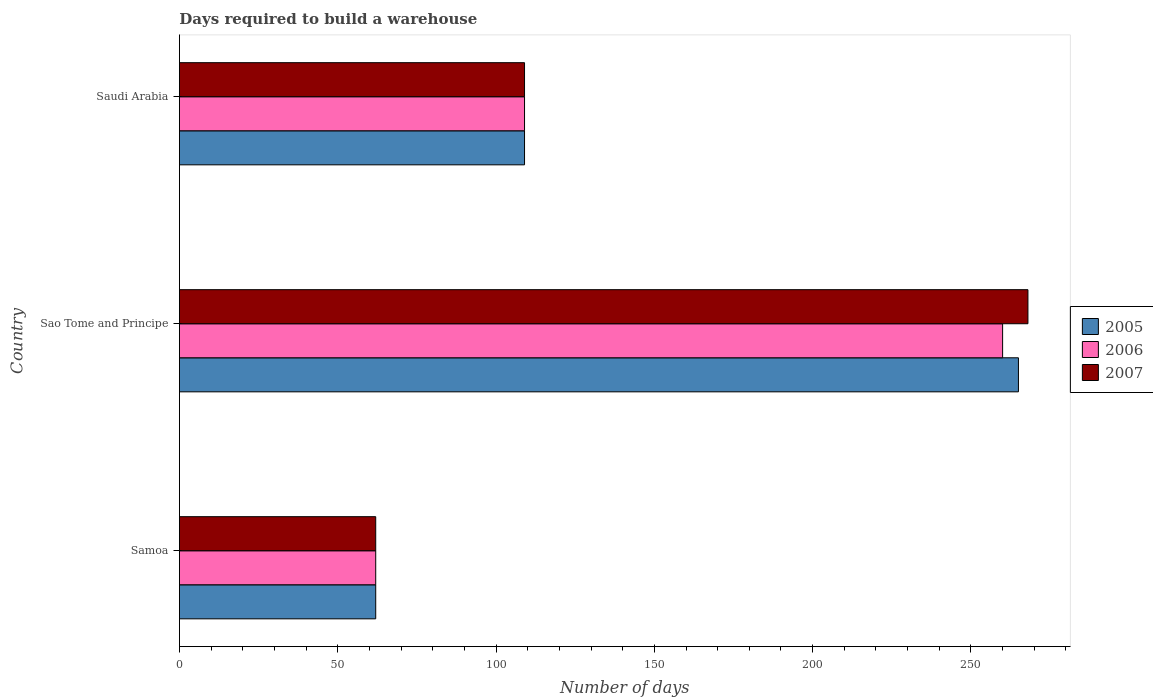How many groups of bars are there?
Ensure brevity in your answer.  3. Are the number of bars per tick equal to the number of legend labels?
Offer a very short reply. Yes. Are the number of bars on each tick of the Y-axis equal?
Your response must be concise. Yes. How many bars are there on the 1st tick from the top?
Ensure brevity in your answer.  3. What is the label of the 2nd group of bars from the top?
Make the answer very short. Sao Tome and Principe. Across all countries, what is the maximum days required to build a warehouse in in 2006?
Your answer should be compact. 260. Across all countries, what is the minimum days required to build a warehouse in in 2005?
Ensure brevity in your answer.  62. In which country was the days required to build a warehouse in in 2005 maximum?
Ensure brevity in your answer.  Sao Tome and Principe. In which country was the days required to build a warehouse in in 2005 minimum?
Your response must be concise. Samoa. What is the total days required to build a warehouse in in 2005 in the graph?
Give a very brief answer. 436. What is the difference between the days required to build a warehouse in in 2007 in Samoa and that in Sao Tome and Principe?
Give a very brief answer. -206. What is the average days required to build a warehouse in in 2007 per country?
Ensure brevity in your answer.  146.33. What is the difference between the days required to build a warehouse in in 2007 and days required to build a warehouse in in 2006 in Saudi Arabia?
Your answer should be compact. 0. In how many countries, is the days required to build a warehouse in in 2006 greater than 210 days?
Provide a succinct answer. 1. What is the ratio of the days required to build a warehouse in in 2005 in Samoa to that in Saudi Arabia?
Keep it short and to the point. 0.57. What is the difference between the highest and the second highest days required to build a warehouse in in 2007?
Ensure brevity in your answer.  159. What is the difference between the highest and the lowest days required to build a warehouse in in 2005?
Provide a succinct answer. 203. Is the sum of the days required to build a warehouse in in 2006 in Samoa and Sao Tome and Principe greater than the maximum days required to build a warehouse in in 2007 across all countries?
Your answer should be very brief. Yes. What does the 2nd bar from the top in Sao Tome and Principe represents?
Your response must be concise. 2006. How many bars are there?
Make the answer very short. 9. Are all the bars in the graph horizontal?
Ensure brevity in your answer.  Yes. How many countries are there in the graph?
Offer a terse response. 3. What is the difference between two consecutive major ticks on the X-axis?
Offer a very short reply. 50. Does the graph contain grids?
Give a very brief answer. No. How are the legend labels stacked?
Your answer should be very brief. Vertical. What is the title of the graph?
Your answer should be very brief. Days required to build a warehouse. What is the label or title of the X-axis?
Give a very brief answer. Number of days. What is the Number of days in 2005 in Samoa?
Your response must be concise. 62. What is the Number of days of 2005 in Sao Tome and Principe?
Provide a succinct answer. 265. What is the Number of days of 2006 in Sao Tome and Principe?
Make the answer very short. 260. What is the Number of days of 2007 in Sao Tome and Principe?
Provide a short and direct response. 268. What is the Number of days in 2005 in Saudi Arabia?
Your answer should be very brief. 109. What is the Number of days of 2006 in Saudi Arabia?
Your answer should be very brief. 109. What is the Number of days in 2007 in Saudi Arabia?
Your answer should be compact. 109. Across all countries, what is the maximum Number of days of 2005?
Make the answer very short. 265. Across all countries, what is the maximum Number of days in 2006?
Keep it short and to the point. 260. Across all countries, what is the maximum Number of days of 2007?
Make the answer very short. 268. Across all countries, what is the minimum Number of days in 2007?
Offer a terse response. 62. What is the total Number of days of 2005 in the graph?
Make the answer very short. 436. What is the total Number of days of 2006 in the graph?
Keep it short and to the point. 431. What is the total Number of days of 2007 in the graph?
Give a very brief answer. 439. What is the difference between the Number of days in 2005 in Samoa and that in Sao Tome and Principe?
Offer a terse response. -203. What is the difference between the Number of days in 2006 in Samoa and that in Sao Tome and Principe?
Offer a very short reply. -198. What is the difference between the Number of days in 2007 in Samoa and that in Sao Tome and Principe?
Your response must be concise. -206. What is the difference between the Number of days of 2005 in Samoa and that in Saudi Arabia?
Your response must be concise. -47. What is the difference between the Number of days in 2006 in Samoa and that in Saudi Arabia?
Give a very brief answer. -47. What is the difference between the Number of days of 2007 in Samoa and that in Saudi Arabia?
Provide a succinct answer. -47. What is the difference between the Number of days in 2005 in Sao Tome and Principe and that in Saudi Arabia?
Give a very brief answer. 156. What is the difference between the Number of days in 2006 in Sao Tome and Principe and that in Saudi Arabia?
Give a very brief answer. 151. What is the difference between the Number of days in 2007 in Sao Tome and Principe and that in Saudi Arabia?
Give a very brief answer. 159. What is the difference between the Number of days of 2005 in Samoa and the Number of days of 2006 in Sao Tome and Principe?
Keep it short and to the point. -198. What is the difference between the Number of days of 2005 in Samoa and the Number of days of 2007 in Sao Tome and Principe?
Provide a succinct answer. -206. What is the difference between the Number of days of 2006 in Samoa and the Number of days of 2007 in Sao Tome and Principe?
Provide a succinct answer. -206. What is the difference between the Number of days in 2005 in Samoa and the Number of days in 2006 in Saudi Arabia?
Your answer should be compact. -47. What is the difference between the Number of days of 2005 in Samoa and the Number of days of 2007 in Saudi Arabia?
Your answer should be compact. -47. What is the difference between the Number of days in 2006 in Samoa and the Number of days in 2007 in Saudi Arabia?
Keep it short and to the point. -47. What is the difference between the Number of days in 2005 in Sao Tome and Principe and the Number of days in 2006 in Saudi Arabia?
Offer a very short reply. 156. What is the difference between the Number of days of 2005 in Sao Tome and Principe and the Number of days of 2007 in Saudi Arabia?
Provide a short and direct response. 156. What is the difference between the Number of days of 2006 in Sao Tome and Principe and the Number of days of 2007 in Saudi Arabia?
Give a very brief answer. 151. What is the average Number of days in 2005 per country?
Your answer should be very brief. 145.33. What is the average Number of days of 2006 per country?
Make the answer very short. 143.67. What is the average Number of days of 2007 per country?
Ensure brevity in your answer.  146.33. What is the difference between the Number of days in 2006 and Number of days in 2007 in Sao Tome and Principe?
Your answer should be compact. -8. What is the difference between the Number of days in 2005 and Number of days in 2007 in Saudi Arabia?
Your answer should be very brief. 0. What is the ratio of the Number of days in 2005 in Samoa to that in Sao Tome and Principe?
Offer a terse response. 0.23. What is the ratio of the Number of days in 2006 in Samoa to that in Sao Tome and Principe?
Ensure brevity in your answer.  0.24. What is the ratio of the Number of days of 2007 in Samoa to that in Sao Tome and Principe?
Your answer should be compact. 0.23. What is the ratio of the Number of days in 2005 in Samoa to that in Saudi Arabia?
Ensure brevity in your answer.  0.57. What is the ratio of the Number of days in 2006 in Samoa to that in Saudi Arabia?
Ensure brevity in your answer.  0.57. What is the ratio of the Number of days in 2007 in Samoa to that in Saudi Arabia?
Your answer should be compact. 0.57. What is the ratio of the Number of days of 2005 in Sao Tome and Principe to that in Saudi Arabia?
Ensure brevity in your answer.  2.43. What is the ratio of the Number of days in 2006 in Sao Tome and Principe to that in Saudi Arabia?
Your response must be concise. 2.39. What is the ratio of the Number of days of 2007 in Sao Tome and Principe to that in Saudi Arabia?
Your response must be concise. 2.46. What is the difference between the highest and the second highest Number of days in 2005?
Provide a succinct answer. 156. What is the difference between the highest and the second highest Number of days of 2006?
Your answer should be very brief. 151. What is the difference between the highest and the second highest Number of days of 2007?
Provide a succinct answer. 159. What is the difference between the highest and the lowest Number of days of 2005?
Provide a short and direct response. 203. What is the difference between the highest and the lowest Number of days of 2006?
Provide a short and direct response. 198. What is the difference between the highest and the lowest Number of days of 2007?
Keep it short and to the point. 206. 